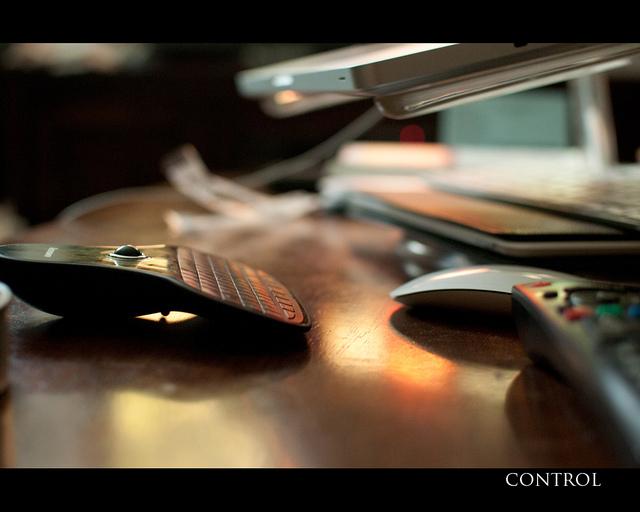What brand of laptop and mouse is shown in this photo?
Quick response, please. Mac. What type of equipment can you see?
Keep it brief. Remote. Are there humans in this picture?
Keep it brief. No. 